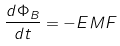<formula> <loc_0><loc_0><loc_500><loc_500>\frac { d \Phi _ { B } } { d t } = - E M F</formula> 